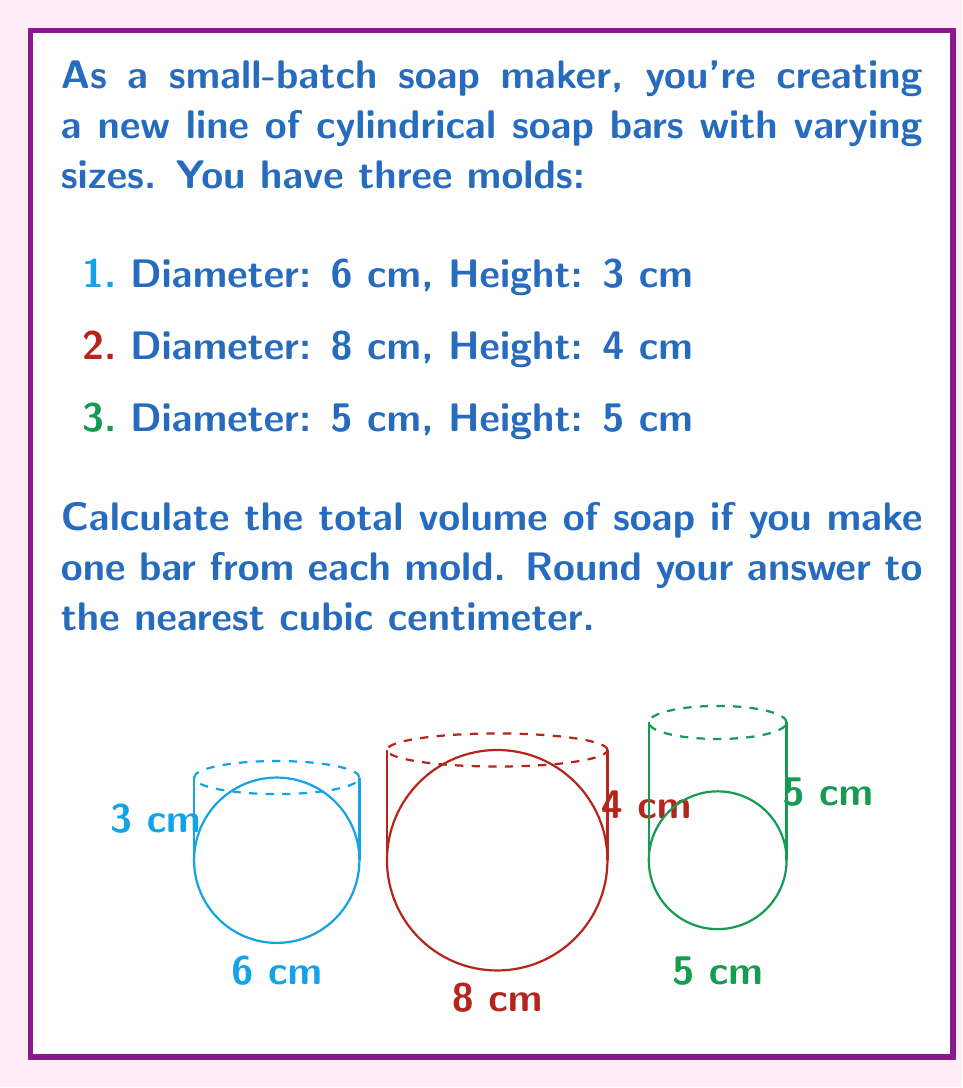Could you help me with this problem? Let's solve this step-by-step using the formula for the volume of a cylinder: $V = \pi r^2 h$, where $r$ is the radius and $h$ is the height.

1. For the first mold (6 cm diameter, 3 cm height):
   $r = 6/2 = 3$ cm
   $V_1 = \pi (3^2)(3) = 27\pi$ cm³

2. For the second mold (8 cm diameter, 4 cm height):
   $r = 8/2 = 4$ cm
   $V_2 = \pi (4^2)(4) = 64\pi$ cm³

3. For the third mold (5 cm diameter, 5 cm height):
   $r = 5/2 = 2.5$ cm
   $V_3 = \pi (2.5^2)(5) = 31.25\pi$ cm³

4. Total volume:
   $V_{total} = V_1 + V_2 + V_3$
   $V_{total} = 27\pi + 64\pi + 31.25\pi$
   $V_{total} = 122.25\pi$ cm³

5. Converting to a numerical value:
   $V_{total} = 122.25 \times 3.14159 \approx 384.04$ cm³

6. Rounding to the nearest cubic centimeter:
   $V_{total} \approx 384$ cm³
Answer: 384 cm³ 